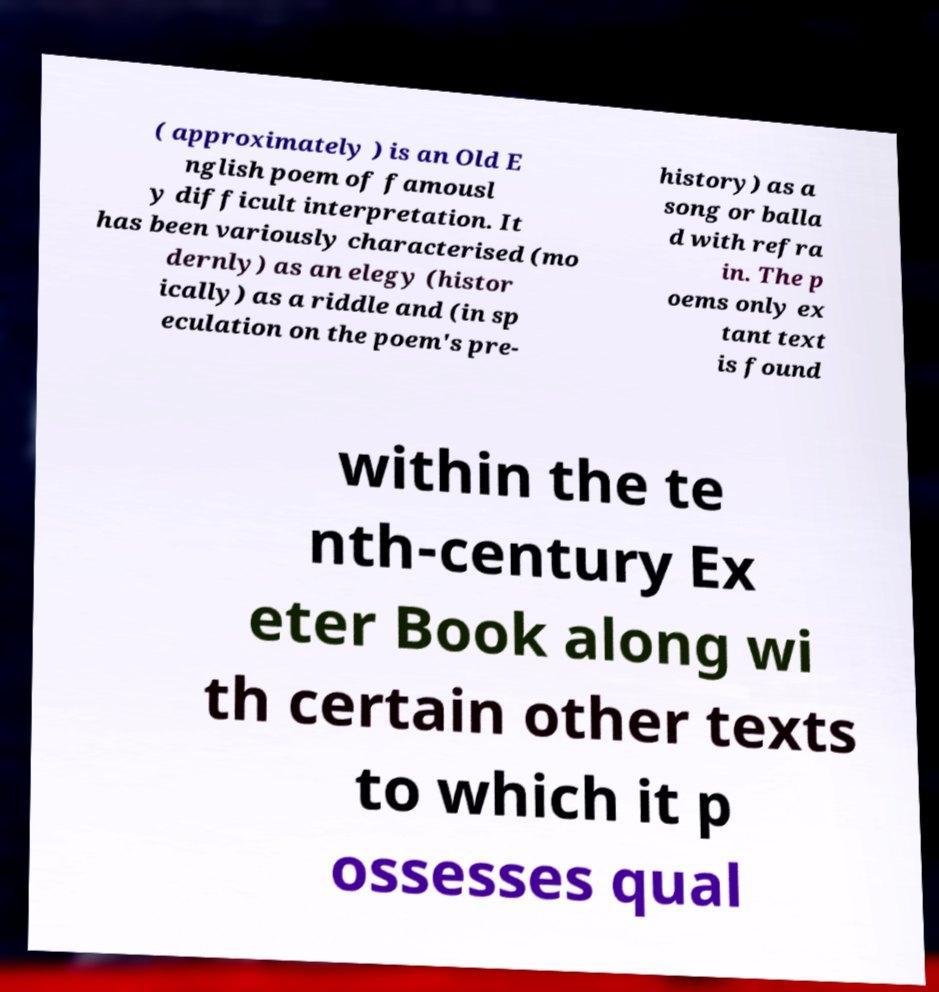Please read and relay the text visible in this image. What does it say? ( approximately ) is an Old E nglish poem of famousl y difficult interpretation. It has been variously characterised (mo dernly) as an elegy (histor ically) as a riddle and (in sp eculation on the poem's pre- history) as a song or balla d with refra in. The p oems only ex tant text is found within the te nth-century Ex eter Book along wi th certain other texts to which it p ossesses qual 